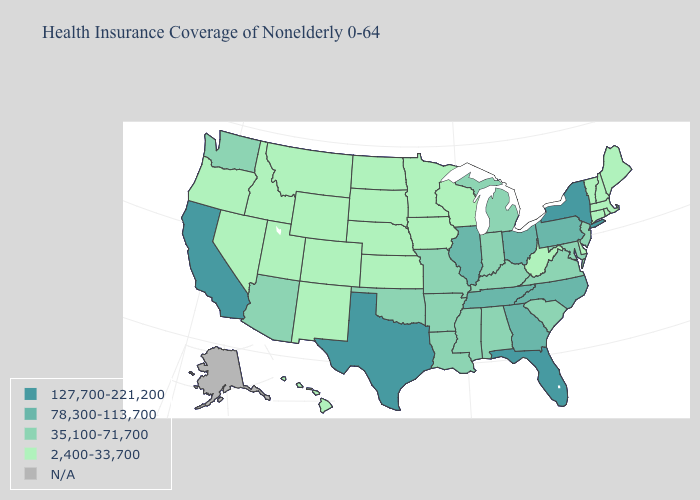Is the legend a continuous bar?
Write a very short answer. No. Does the first symbol in the legend represent the smallest category?
Be succinct. No. Among the states that border Tennessee , which have the highest value?
Answer briefly. Georgia, North Carolina. Which states hav the highest value in the West?
Quick response, please. California. What is the highest value in the USA?
Be succinct. 127,700-221,200. What is the lowest value in the West?
Give a very brief answer. 2,400-33,700. Which states have the lowest value in the USA?
Write a very short answer. Colorado, Connecticut, Delaware, Hawaii, Idaho, Iowa, Kansas, Maine, Massachusetts, Minnesota, Montana, Nebraska, Nevada, New Hampshire, New Mexico, North Dakota, Oregon, Rhode Island, South Dakota, Utah, Vermont, West Virginia, Wisconsin, Wyoming. Is the legend a continuous bar?
Write a very short answer. No. What is the highest value in the USA?
Write a very short answer. 127,700-221,200. Does Mississippi have the lowest value in the USA?
Keep it brief. No. How many symbols are there in the legend?
Give a very brief answer. 5. Name the states that have a value in the range 35,100-71,700?
Keep it brief. Alabama, Arizona, Arkansas, Indiana, Kentucky, Louisiana, Maryland, Michigan, Mississippi, Missouri, New Jersey, Oklahoma, South Carolina, Virginia, Washington. Which states hav the highest value in the South?
Give a very brief answer. Florida, Texas. What is the value of Nevada?
Write a very short answer. 2,400-33,700. 